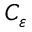<formula> <loc_0><loc_0><loc_500><loc_500>C _ { \varepsilon }</formula> 